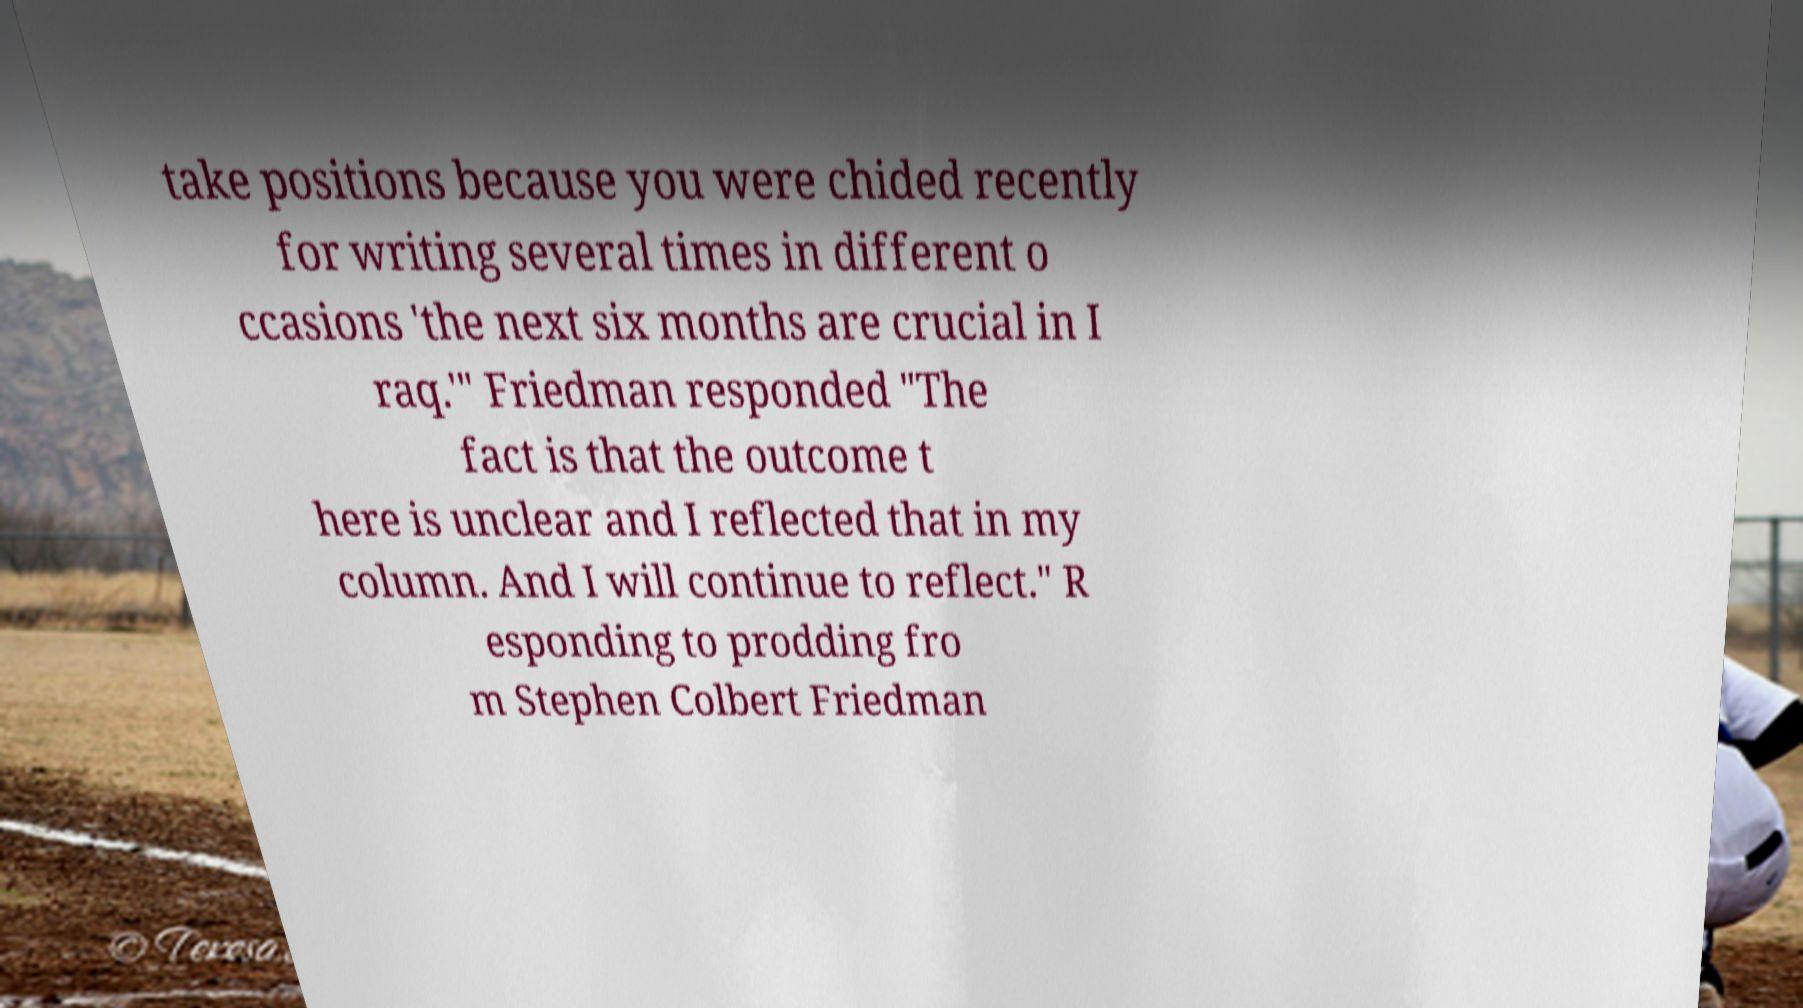Could you assist in decoding the text presented in this image and type it out clearly? take positions because you were chided recently for writing several times in different o ccasions 'the next six months are crucial in I raq.'" Friedman responded "The fact is that the outcome t here is unclear and I reflected that in my column. And I will continue to reflect." R esponding to prodding fro m Stephen Colbert Friedman 